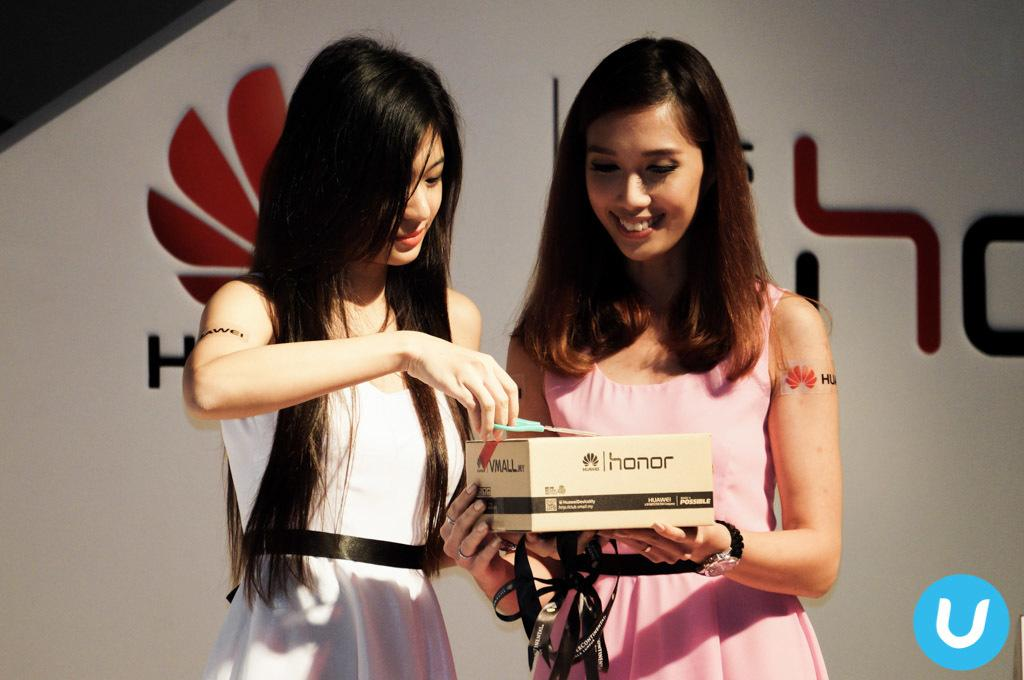How many people are in the image? There are two ladies in the image. What is one of the ladies holding? One of the ladies is holding a box. What is the other lady holding? The other lady is holding a pair of scissors. What type of lunch is being prepared by the ladies in the image? There is no indication of lunch preparation in the image; the ladies are holding a box and a pair of scissors. 